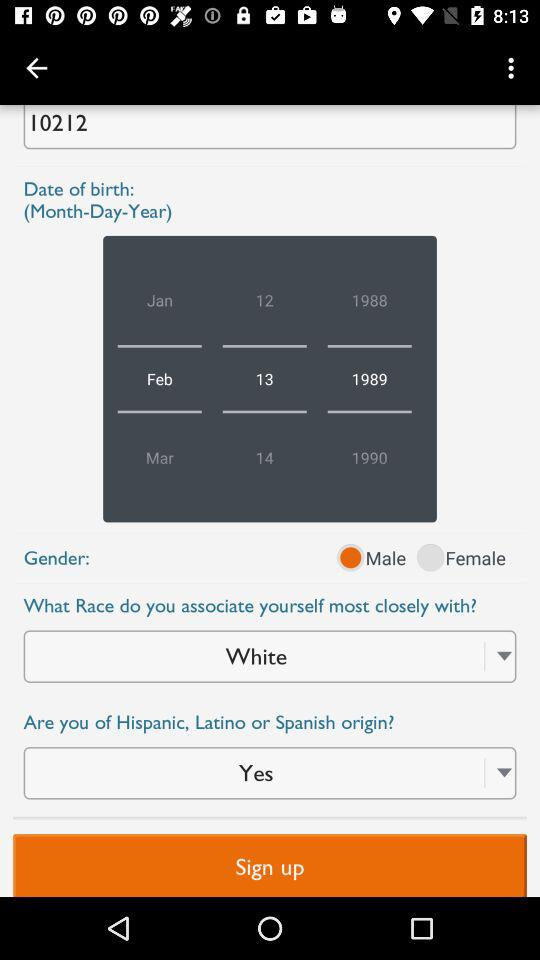What's the date of birth format? The date of birth format is "(Month-Day-Year)". 